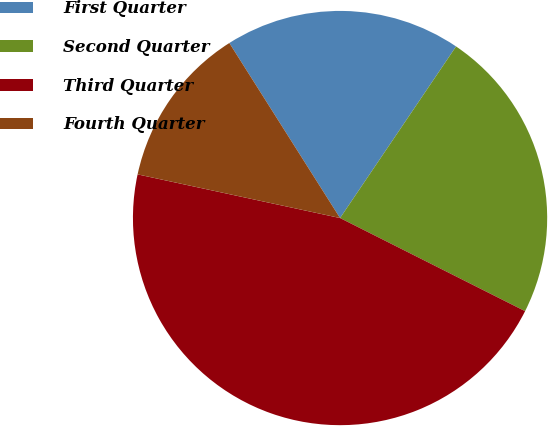Convert chart. <chart><loc_0><loc_0><loc_500><loc_500><pie_chart><fcel>First Quarter<fcel>Second Quarter<fcel>Third Quarter<fcel>Fourth Quarter<nl><fcel>18.44%<fcel>22.96%<fcel>45.96%<fcel>12.64%<nl></chart> 